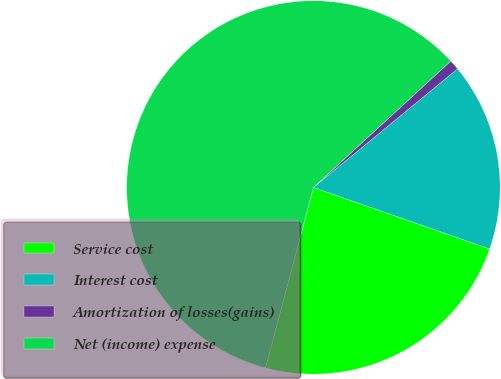<chart> <loc_0><loc_0><loc_500><loc_500><pie_chart><fcel>Service cost<fcel>Interest cost<fcel>Amortization of losses(gains)<fcel>Net (income) expense<nl><fcel>23.79%<fcel>16.3%<fcel>0.88%<fcel>59.03%<nl></chart> 